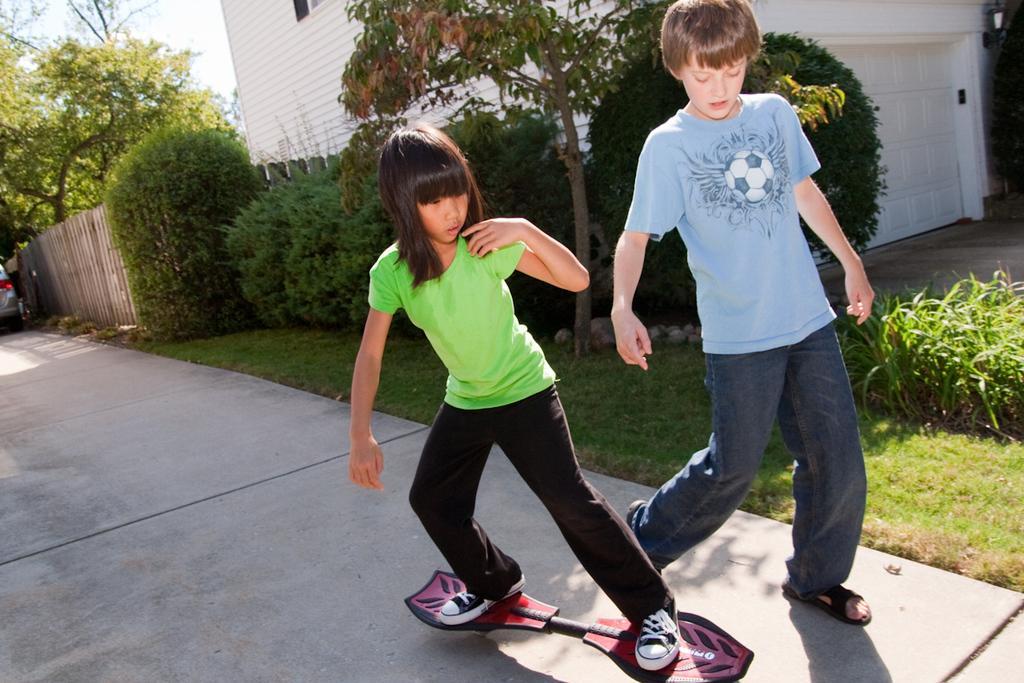Could you give a brief overview of what you see in this image? In this picture I can see two person's, a person standing on the skateboard, there is grass, plants, fence, trees, this is looking like a house, there is a vehicle, and in the background there is sky. 